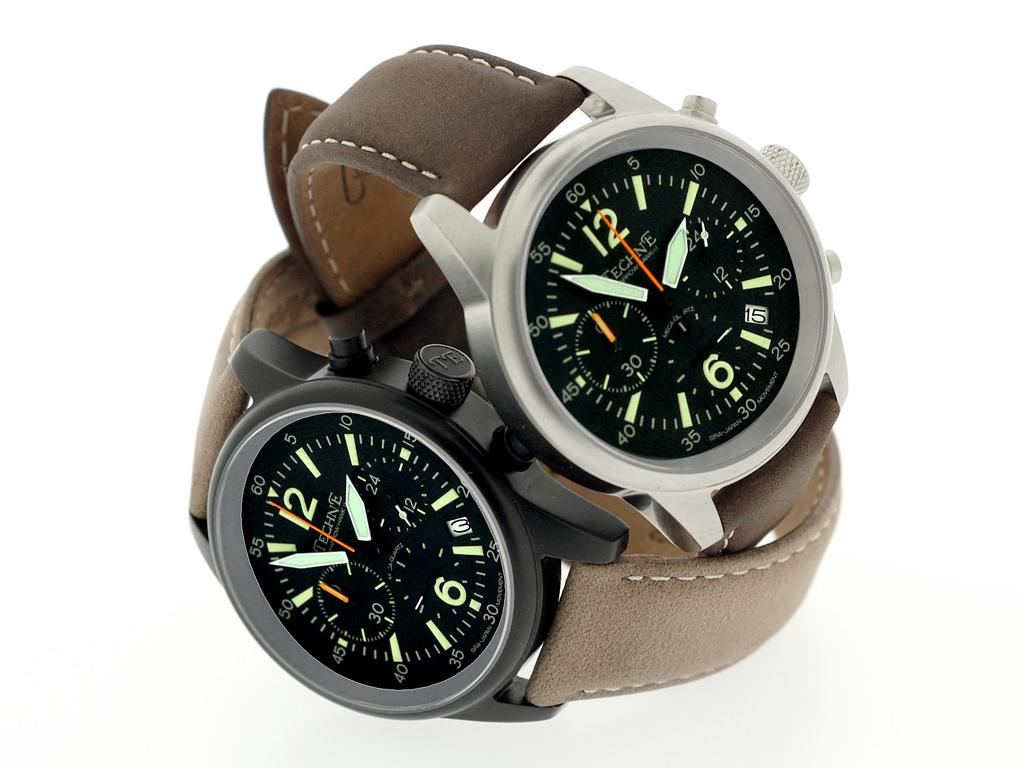Provide a one-sentence caption for the provided image. Two watches are on top of each other with the top one reading almost 1:55. 